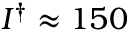<formula> <loc_0><loc_0><loc_500><loc_500>I ^ { \dag } \approx 1 5 0</formula> 